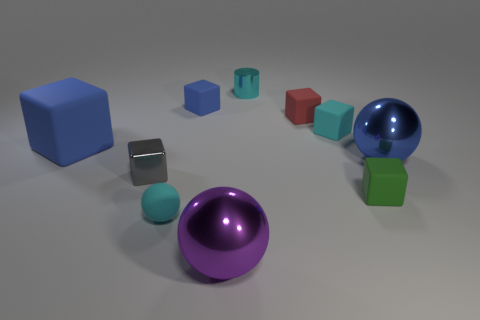Subtract all cyan cubes. How many cubes are left? 5 Subtract all small green matte blocks. How many blocks are left? 5 Subtract all green blocks. Subtract all brown cylinders. How many blocks are left? 5 Subtract all cylinders. How many objects are left? 9 Add 1 rubber things. How many rubber things exist? 7 Subtract 0 gray balls. How many objects are left? 10 Subtract all small cyan metal things. Subtract all tiny balls. How many objects are left? 8 Add 4 gray shiny things. How many gray shiny things are left? 5 